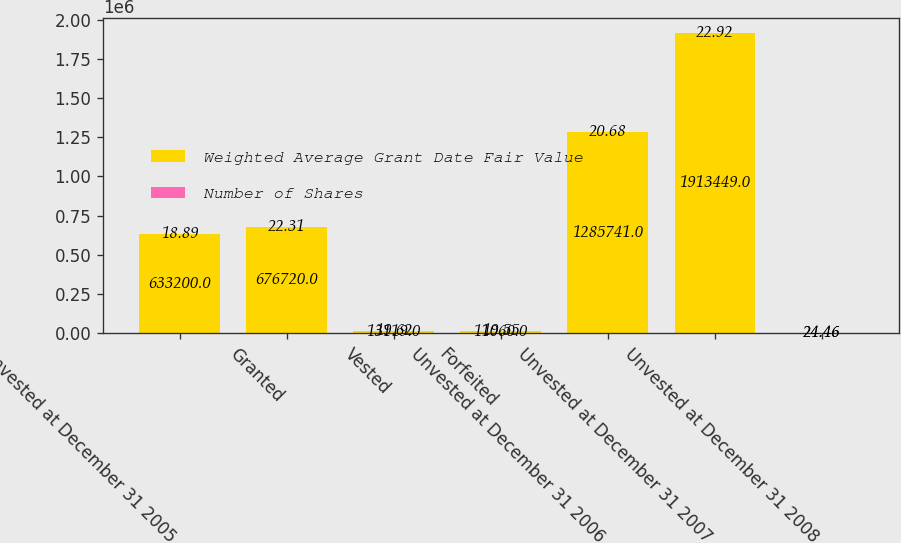Convert chart. <chart><loc_0><loc_0><loc_500><loc_500><stacked_bar_chart><ecel><fcel>Unvested at December 31 2005<fcel>Granted<fcel>Vested<fcel>Forfeited<fcel>Unvested at December 31 2006<fcel>Unvested at December 31 2007<fcel>Unvested at December 31 2008<nl><fcel>Weighted Average Grant Date Fair Value<fcel>633200<fcel>676720<fcel>13119<fcel>11060<fcel>1.28574e+06<fcel>1.91345e+06<fcel>24.46<nl><fcel>Number of Shares<fcel>18.89<fcel>22.31<fcel>19.62<fcel>19.55<fcel>20.68<fcel>22.92<fcel>24.46<nl></chart> 